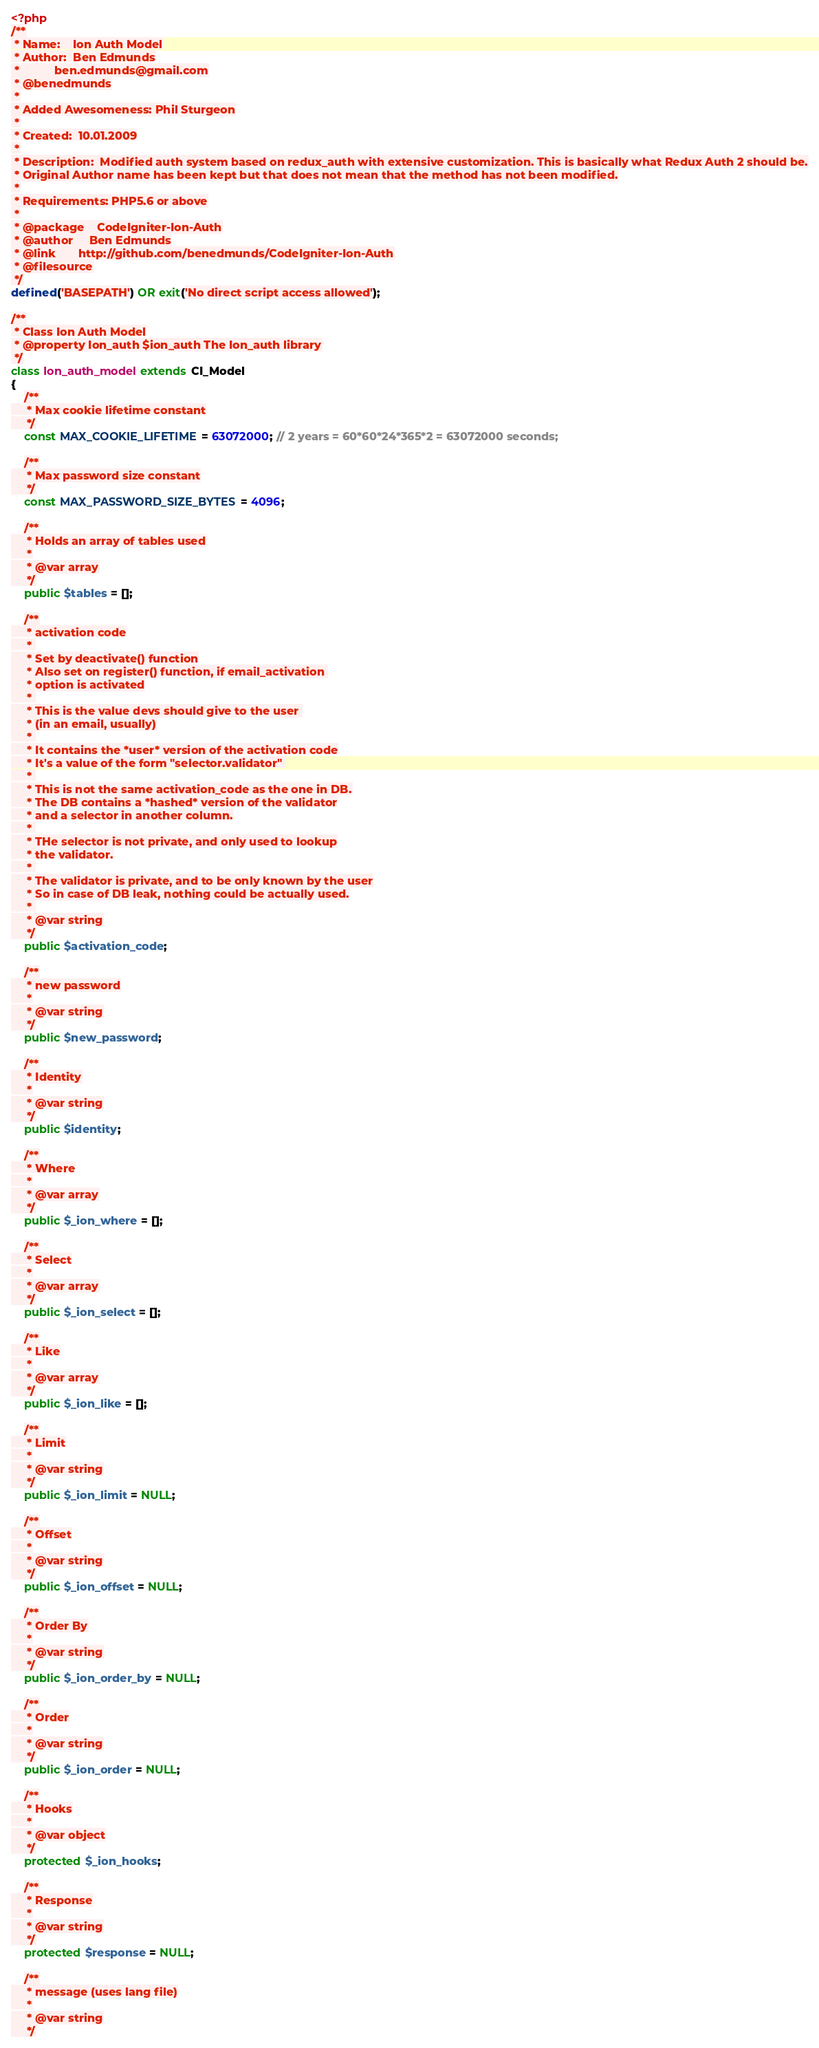Convert code to text. <code><loc_0><loc_0><loc_500><loc_500><_PHP_><?php
/**
 * Name:    Ion Auth Model
 * Author:  Ben Edmunds
 *           ben.edmunds@gmail.com
 * @benedmunds
 *
 * Added Awesomeness: Phil Sturgeon
 *
 * Created:  10.01.2009
 *
 * Description:  Modified auth system based on redux_auth with extensive customization. This is basically what Redux Auth 2 should be.
 * Original Author name has been kept but that does not mean that the method has not been modified.
 *
 * Requirements: PHP5.6 or above
 *
 * @package    CodeIgniter-Ion-Auth
 * @author     Ben Edmunds
 * @link       http://github.com/benedmunds/CodeIgniter-Ion-Auth
 * @filesource
 */
defined('BASEPATH') OR exit('No direct script access allowed');

/**
 * Class Ion Auth Model
 * @property Ion_auth $ion_auth The Ion_auth library
 */
class Ion_auth_model extends CI_Model
{
	/**
	 * Max cookie lifetime constant
	 */
	const MAX_COOKIE_LIFETIME = 63072000; // 2 years = 60*60*24*365*2 = 63072000 seconds;

	/**
	 * Max password size constant
	 */
	const MAX_PASSWORD_SIZE_BYTES = 4096;

	/**
	 * Holds an array of tables used
	 *
	 * @var array
	 */
	public $tables = [];

	/**
	 * activation code
	 * 
	 * Set by deactivate() function
	 * Also set on register() function, if email_activation 
	 * option is activated
	 * 
	 * This is the value devs should give to the user 
	 * (in an email, usually)
	 * 
	 * It contains the *user* version of the activation code
	 * It's a value of the form "selector.validator" 
	 * 
	 * This is not the same activation_code as the one in DB.
	 * The DB contains a *hashed* version of the validator
	 * and a selector in another column.
	 * 
	 * THe selector is not private, and only used to lookup
	 * the validator.
	 * 
	 * The validator is private, and to be only known by the user
	 * So in case of DB leak, nothing could be actually used.
	 * 
	 * @var string
	 */
	public $activation_code;

	/**
	 * new password
	 *
	 * @var string
	 */
	public $new_password;

	/**
	 * Identity
	 *
	 * @var string
	 */
	public $identity;

	/**
	 * Where
	 *
	 * @var array
	 */
	public $_ion_where = [];

	/**
	 * Select
	 *
	 * @var array
	 */
	public $_ion_select = [];

	/**
	 * Like
	 *
	 * @var array
	 */
	public $_ion_like = [];

	/**
	 * Limit
	 *
	 * @var string
	 */
	public $_ion_limit = NULL;

	/**
	 * Offset
	 *
	 * @var string
	 */
	public $_ion_offset = NULL;

	/**
	 * Order By
	 *
	 * @var string
	 */
	public $_ion_order_by = NULL;

	/**
	 * Order
	 *
	 * @var string
	 */
	public $_ion_order = NULL;

	/**
	 * Hooks
	 *
	 * @var object
	 */
	protected $_ion_hooks;

	/**
	 * Response
	 *
	 * @var string
	 */
	protected $response = NULL;

	/**
	 * message (uses lang file)
	 *
	 * @var string
	 */</code> 